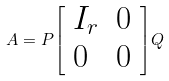Convert formula to latex. <formula><loc_0><loc_0><loc_500><loc_500>A = P { \left [ \begin{array} { l l } { I _ { r } } & { 0 } \\ { 0 } & { 0 } \end{array} \right ] } Q</formula> 